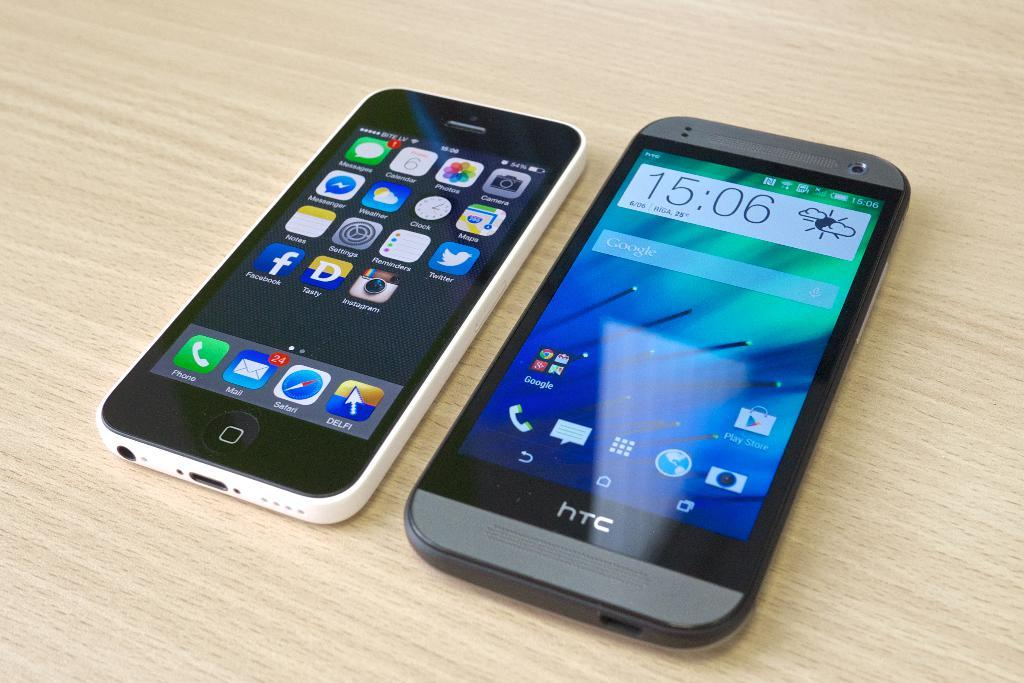<image>
Relay a brief, clear account of the picture shown. Two smartphones lie next to each other on a table at 15:06. 